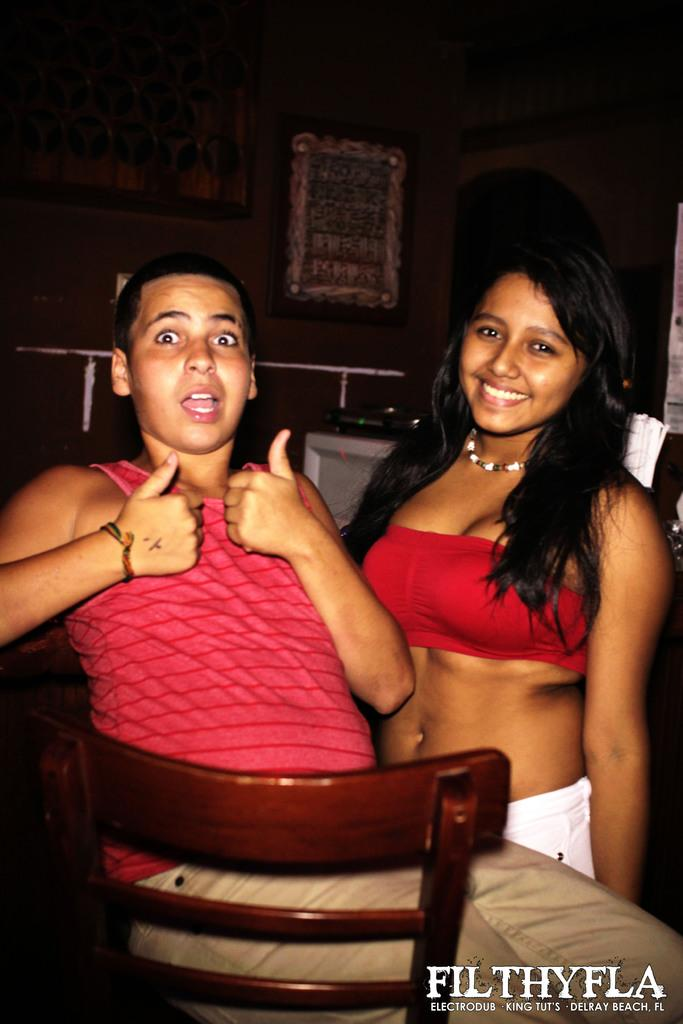How many people are in the image? There are two persons in the image. Can you describe the gender of each person? One person is a man, and the other person is a woman. What is the man doing in the image? The man is sitting on a chair. How is the woman positioned in relation to the man? The woman is standing beside the man. What can be seen in the background of the image? There is a wall in the background of the image, and there are frames on the wall. What type of suggestion can be seen written on the stocking in the image? There is no stocking present in the image, and therefore no suggestion can be seen. 